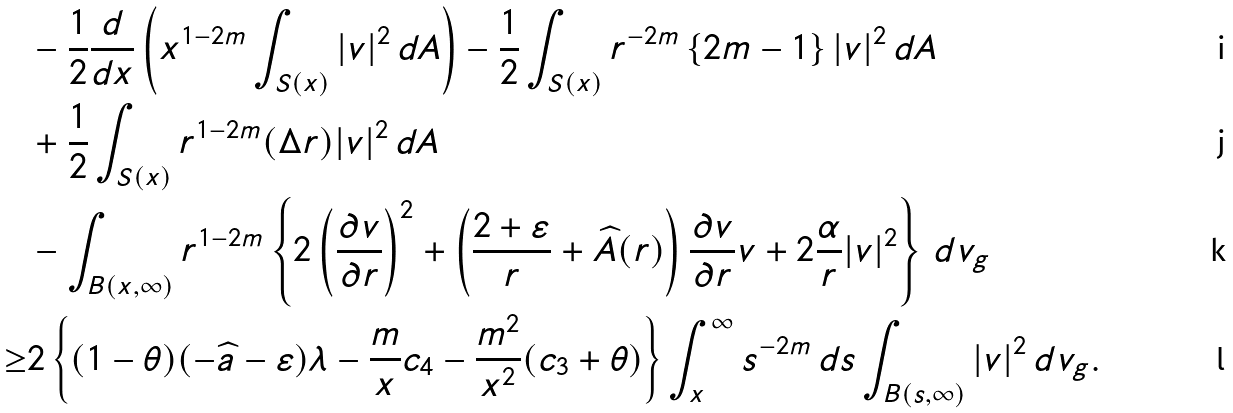Convert formula to latex. <formula><loc_0><loc_0><loc_500><loc_500>& - \frac { 1 } { 2 } \frac { d } { d x } \left ( x ^ { 1 - 2 m } \int _ { S ( x ) } | v | ^ { 2 } \, d A \right ) - \frac { 1 } { 2 } \int _ { S ( x ) } r ^ { - 2 m } \left \{ 2 m - 1 \right \} | v | ^ { 2 } \, d A \\ & + \frac { 1 } { 2 } \int _ { S ( x ) } r ^ { 1 - 2 m } ( \Delta r ) | v | ^ { 2 } \, d A \\ & - \int _ { B ( x , \infty ) } r ^ { 1 - 2 m } \left \{ 2 \left ( \frac { \partial v } { \partial r } \right ) ^ { 2 } + \left ( \frac { 2 + \varepsilon } { r } + \widehat { A } ( r ) \right ) \frac { \partial v } { \partial r } v + 2 \frac { \alpha } { r } | v | ^ { 2 } \right \} \, d v _ { g } \\ \geq & 2 \left \{ ( 1 - \theta ) ( - \widehat { a } - \varepsilon ) \lambda - \frac { m } { x } c _ { 4 } - \frac { m ^ { 2 } } { x ^ { 2 } } ( c _ { 3 } + \theta ) \right \} \int _ { x } ^ { \infty } s ^ { - 2 m } \, d s \int _ { B ( s , \infty ) } | v | ^ { 2 } \, d v _ { g } .</formula> 